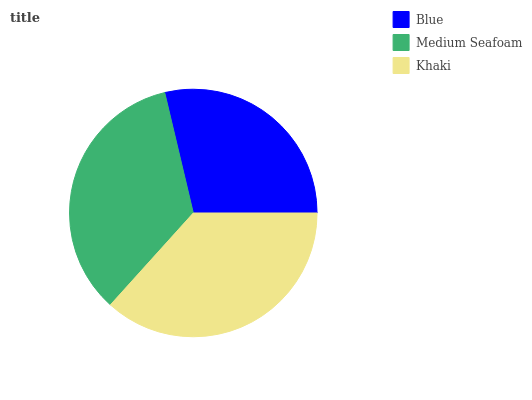Is Blue the minimum?
Answer yes or no. Yes. Is Khaki the maximum?
Answer yes or no. Yes. Is Medium Seafoam the minimum?
Answer yes or no. No. Is Medium Seafoam the maximum?
Answer yes or no. No. Is Medium Seafoam greater than Blue?
Answer yes or no. Yes. Is Blue less than Medium Seafoam?
Answer yes or no. Yes. Is Blue greater than Medium Seafoam?
Answer yes or no. No. Is Medium Seafoam less than Blue?
Answer yes or no. No. Is Medium Seafoam the high median?
Answer yes or no. Yes. Is Medium Seafoam the low median?
Answer yes or no. Yes. Is Blue the high median?
Answer yes or no. No. Is Khaki the low median?
Answer yes or no. No. 